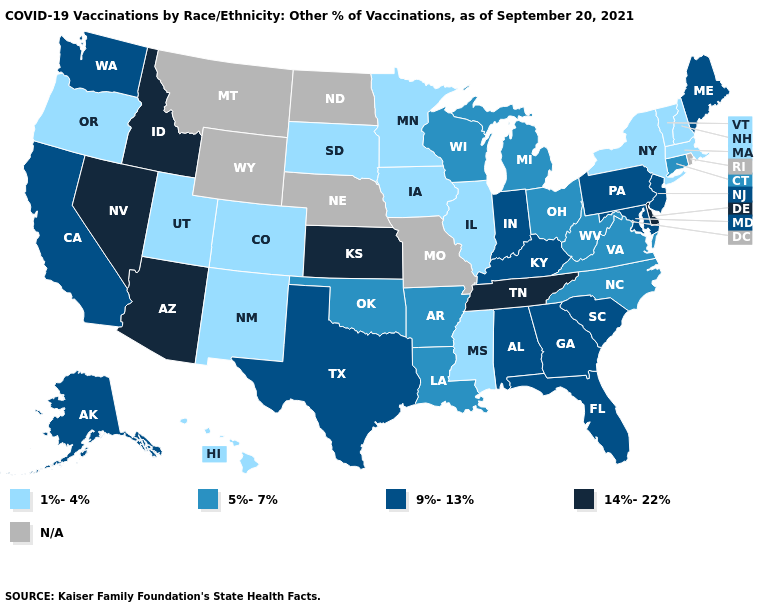What is the value of Wyoming?
Give a very brief answer. N/A. Does the map have missing data?
Concise answer only. Yes. Which states hav the highest value in the MidWest?
Quick response, please. Kansas. What is the highest value in the USA?
Be succinct. 14%-22%. Name the states that have a value in the range 1%-4%?
Short answer required. Colorado, Hawaii, Illinois, Iowa, Massachusetts, Minnesota, Mississippi, New Hampshire, New Mexico, New York, Oregon, South Dakota, Utah, Vermont. Among the states that border Washington , does Idaho have the highest value?
Concise answer only. Yes. What is the highest value in the South ?
Keep it brief. 14%-22%. What is the value of North Carolina?
Keep it brief. 5%-7%. Name the states that have a value in the range 14%-22%?
Answer briefly. Arizona, Delaware, Idaho, Kansas, Nevada, Tennessee. What is the value of Arizona?
Quick response, please. 14%-22%. What is the value of Pennsylvania?
Quick response, please. 9%-13%. Name the states that have a value in the range 14%-22%?
Quick response, please. Arizona, Delaware, Idaho, Kansas, Nevada, Tennessee. Name the states that have a value in the range 9%-13%?
Answer briefly. Alabama, Alaska, California, Florida, Georgia, Indiana, Kentucky, Maine, Maryland, New Jersey, Pennsylvania, South Carolina, Texas, Washington. What is the value of New Hampshire?
Be succinct. 1%-4%. 